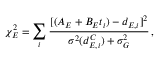Convert formula to latex. <formula><loc_0><loc_0><loc_500><loc_500>\chi _ { E } ^ { 2 } = \sum _ { i } \frac { [ ( A _ { E } + B _ { E } t _ { i } ) - d _ { E , i } ] ^ { 2 } } { \sigma ^ { 2 } ( d _ { E , i } ^ { C } ) + \sigma _ { G } ^ { 2 } } \, ,</formula> 